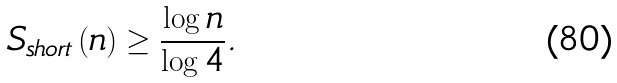Convert formula to latex. <formula><loc_0><loc_0><loc_500><loc_500>S _ { s h o r t } \left ( n \right ) \geq \frac { \log n } { \log 4 } .</formula> 